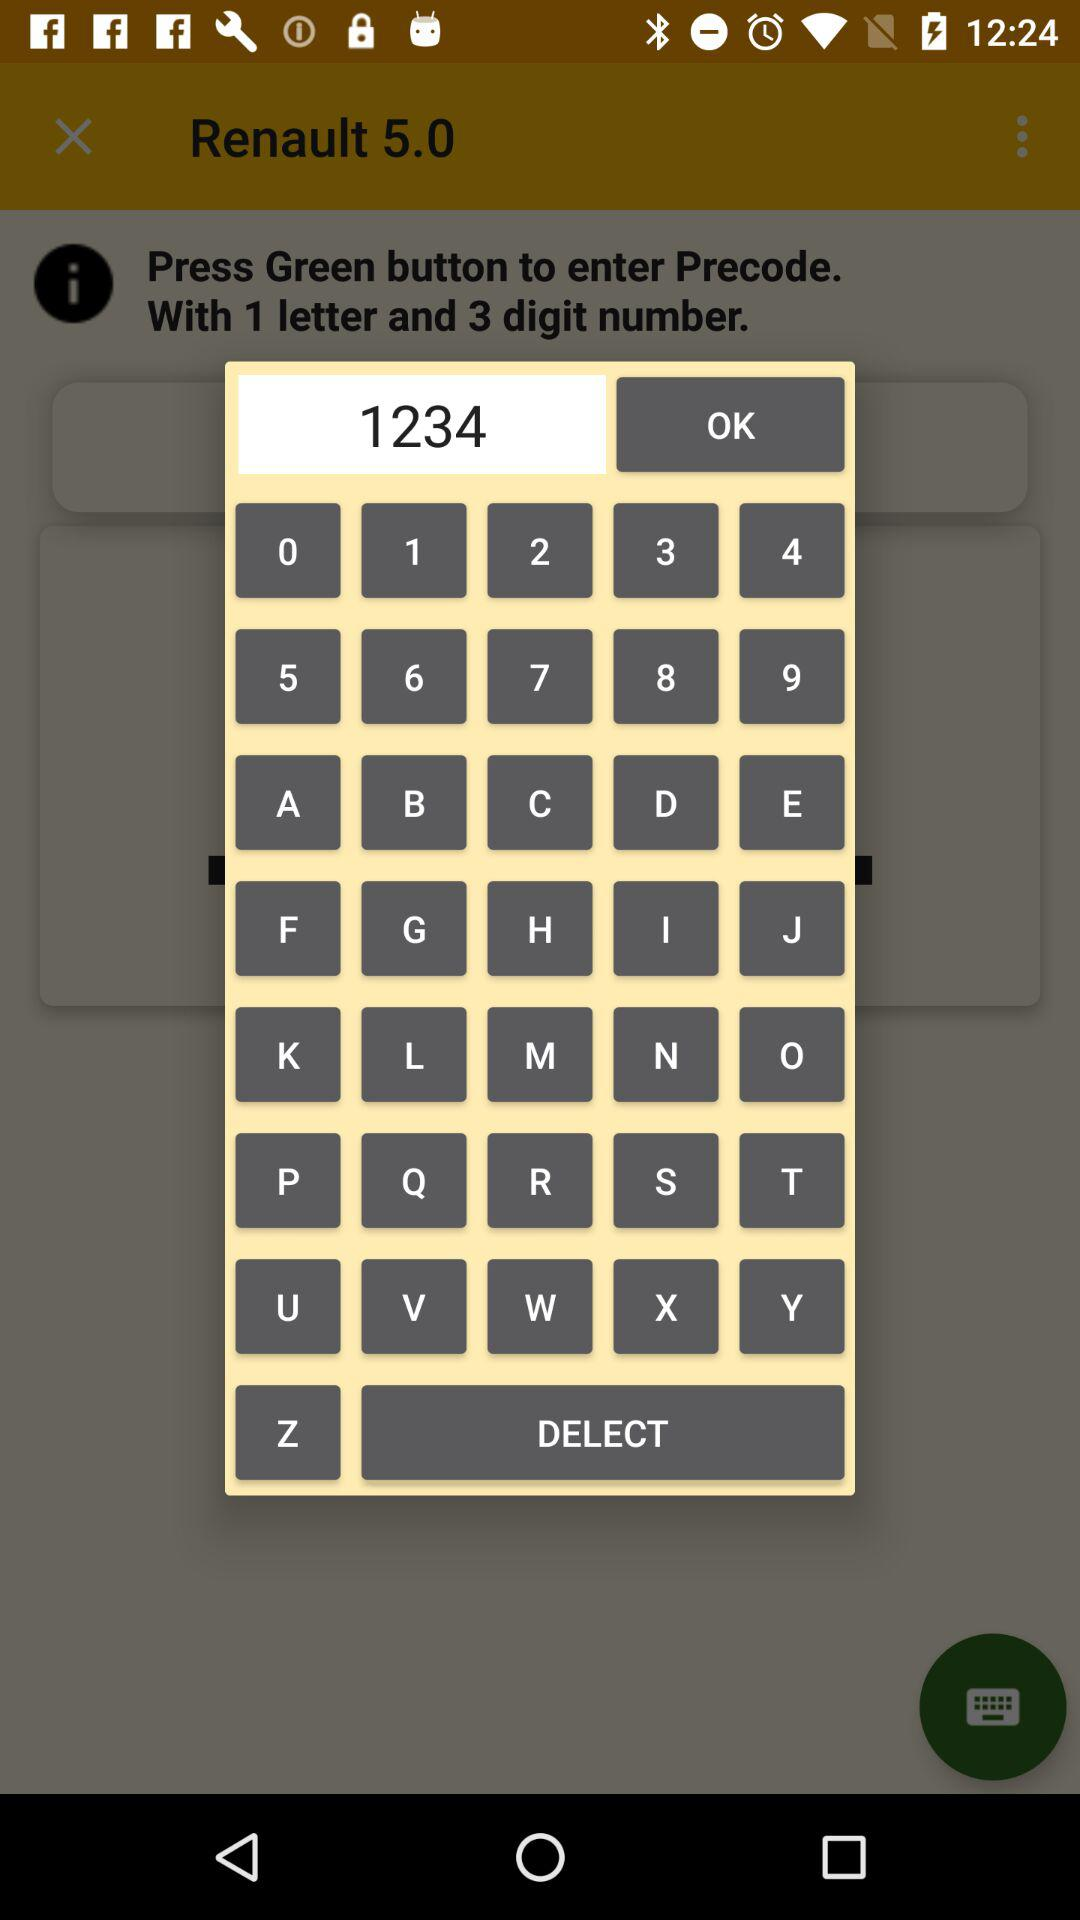What is the version of renault?
When the provided information is insufficient, respond with <no answer>. <no answer> 